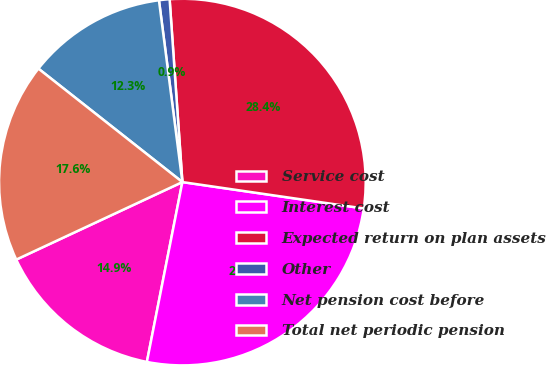Convert chart to OTSL. <chart><loc_0><loc_0><loc_500><loc_500><pie_chart><fcel>Service cost<fcel>Interest cost<fcel>Expected return on plan assets<fcel>Other<fcel>Net pension cost before<fcel>Total net periodic pension<nl><fcel>14.95%<fcel>25.8%<fcel>28.41%<fcel>0.93%<fcel>12.34%<fcel>17.57%<nl></chart> 